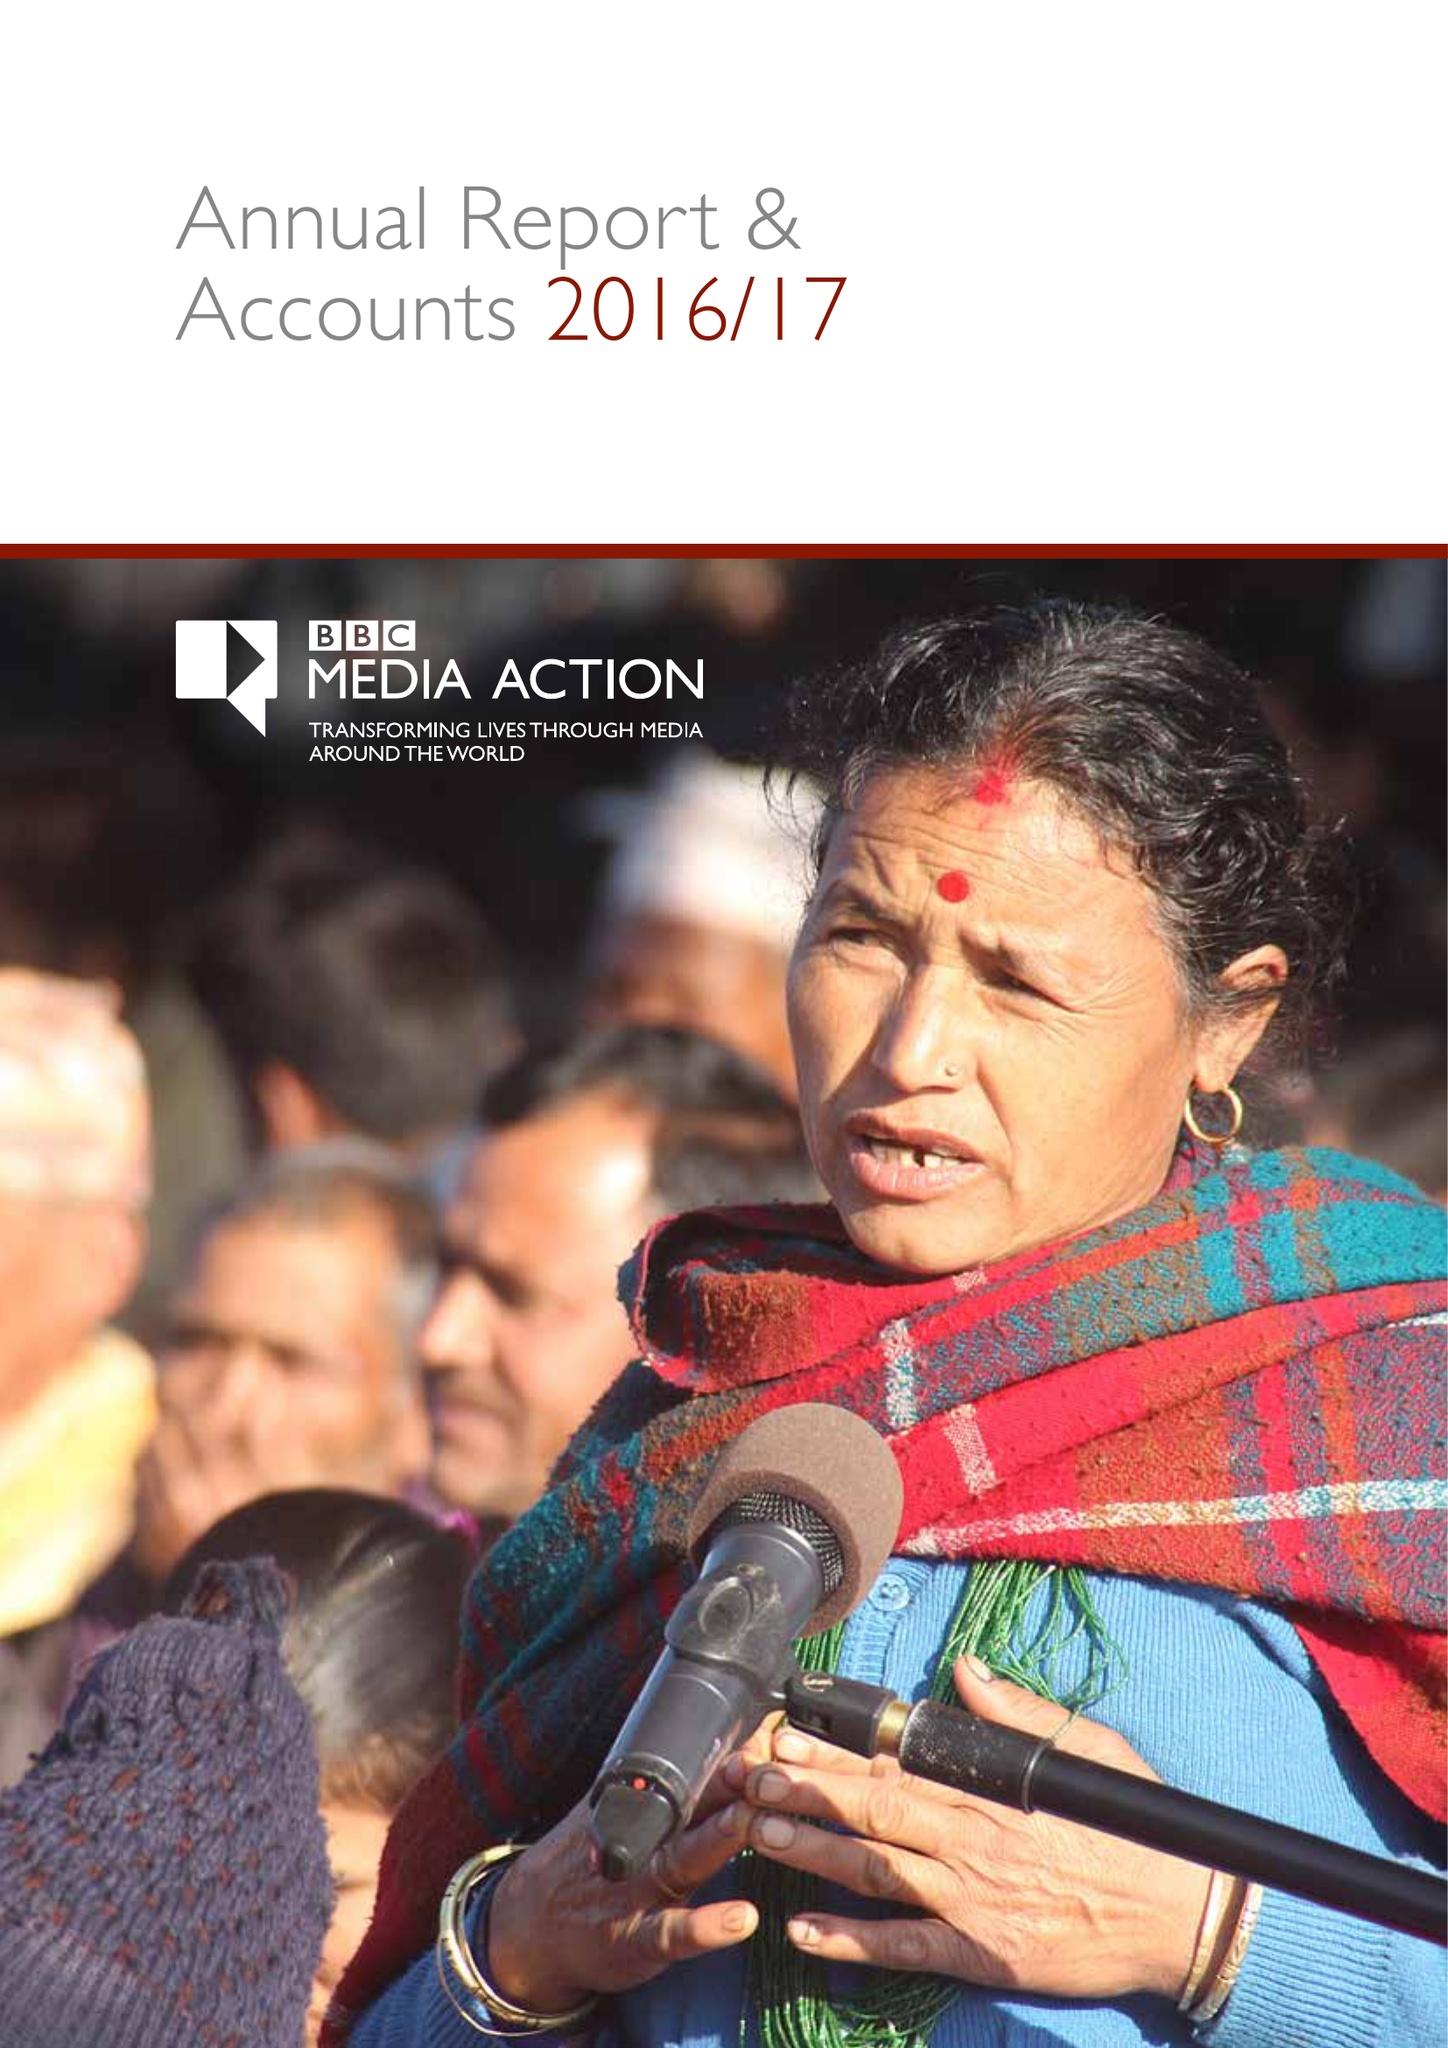What is the value for the spending_annually_in_british_pounds?
Answer the question using a single word or phrase. 43763000.00 